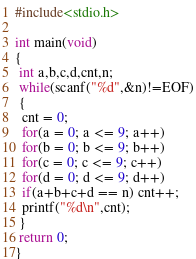<code> <loc_0><loc_0><loc_500><loc_500><_C_>#include<stdio.h>
 
int main(void)
{
 int a,b,c,d,cnt,n;
 while(scanf("%d",&n)!=EOF)
 {
  cnt = 0;
  for(a = 0; a <= 9; a++)
  for(b = 0; b <= 9; b++)
  for(c = 0; c <= 9; c++)
  for(d = 0; d <= 9; d++)
  if(a+b+c+d == n) cnt++;
  printf("%d\n",cnt);
 }
 return 0;
}</code> 